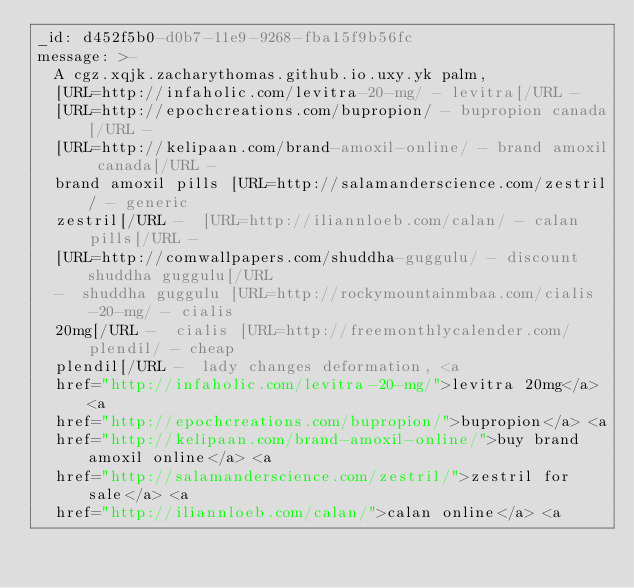<code> <loc_0><loc_0><loc_500><loc_500><_YAML_>_id: d452f5b0-d0b7-11e9-9268-fba15f9b56fc
message: >-
  A cgz.xqjk.zacharythomas.github.io.uxy.yk palm,
  [URL=http://infaholic.com/levitra-20-mg/ - levitra[/URL - 
  [URL=http://epochcreations.com/bupropion/ - bupropion canada[/URL - 
  [URL=http://kelipaan.com/brand-amoxil-online/ - brand amoxil canada[/URL - 
  brand amoxil pills [URL=http://salamanderscience.com/zestril/ - generic
  zestril[/URL -  [URL=http://iliannloeb.com/calan/ - calan pills[/URL - 
  [URL=http://comwallpapers.com/shuddha-guggulu/ - discount shuddha guggulu[/URL
  -  shuddha guggulu [URL=http://rockymountainmbaa.com/cialis-20-mg/ - cialis
  20mg[/URL -  cialis [URL=http://freemonthlycalender.com/plendil/ - cheap
  plendil[/URL -  lady changes deformation, <a
  href="http://infaholic.com/levitra-20-mg/">levitra 20mg</a> <a
  href="http://epochcreations.com/bupropion/">bupropion</a> <a
  href="http://kelipaan.com/brand-amoxil-online/">buy brand amoxil online</a> <a
  href="http://salamanderscience.com/zestril/">zestril for sale</a> <a
  href="http://iliannloeb.com/calan/">calan online</a> <a</code> 